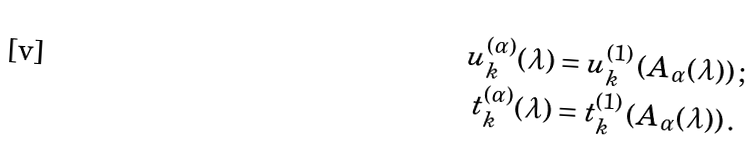<formula> <loc_0><loc_0><loc_500><loc_500>u _ { k } ^ { ( \alpha ) } ( \lambda ) & = u _ { k } ^ { ( 1 ) } \left ( A _ { \alpha } ( \lambda ) \right ) ; \\ t _ { k } ^ { ( \alpha ) } ( \lambda ) & = t _ { k } ^ { ( 1 ) } \left ( A _ { \alpha } ( \lambda ) \right ) .</formula> 